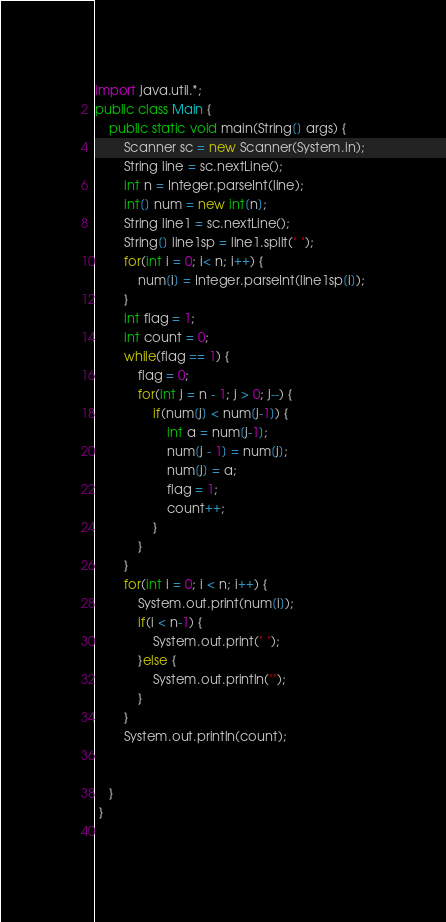Convert code to text. <code><loc_0><loc_0><loc_500><loc_500><_Java_>import java.util.*;
public class Main {
    public static void main(String[] args) {
        Scanner sc = new Scanner(System.in);
        String line = sc.nextLine();
        int n = Integer.parseInt(line);
        int[] num = new int[n];
        String line1 = sc.nextLine();
        String[] line1sp = line1.split(" ");
        for(int i = 0; i< n; i++) {
            num[i] = Integer.parseInt(line1sp[i]);
        }
        int flag = 1;
        int count = 0;
        while(flag == 1) {
            flag = 0;
            for(int j = n - 1; j > 0; j--) {
                if(num[j] < num[j-1]) {
                    int a = num[j-1];
                    num[j - 1] = num[j];
                    num[j] = a;
                    flag = 1;
                    count++;
                }
            }
        } 
        for(int i = 0; i < n; i++) {
            System.out.print(num[i]);
            if(i < n-1) {
                System.out.print(" ");
            }else {
                System.out.println("");
            }
        }
        System.out.println(count);
            
            
    }
 }
 
</code> 